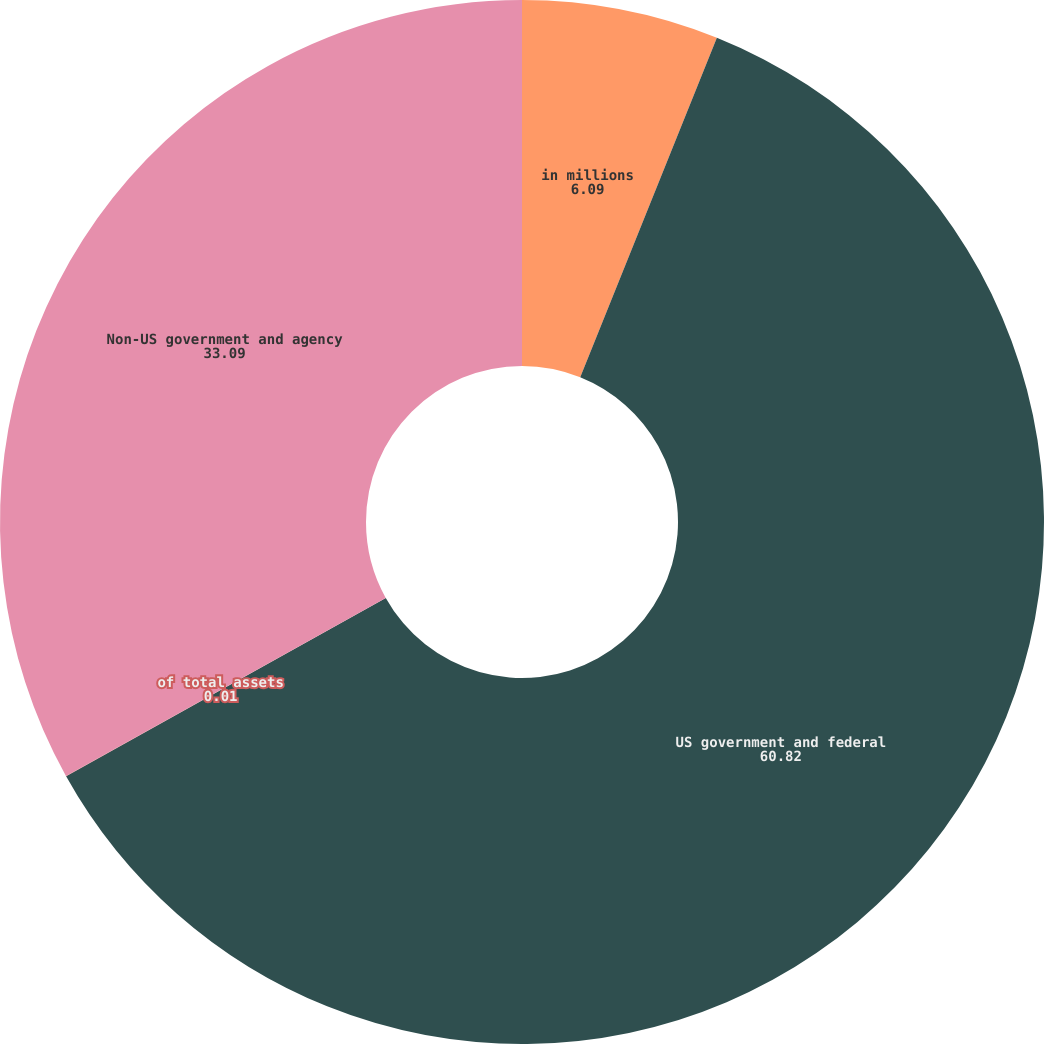<chart> <loc_0><loc_0><loc_500><loc_500><pie_chart><fcel>in millions<fcel>US government and federal<fcel>of total assets<fcel>Non-US government and agency<nl><fcel>6.09%<fcel>60.82%<fcel>0.01%<fcel>33.09%<nl></chart> 